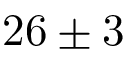<formula> <loc_0><loc_0><loc_500><loc_500>2 6 \pm 3</formula> 